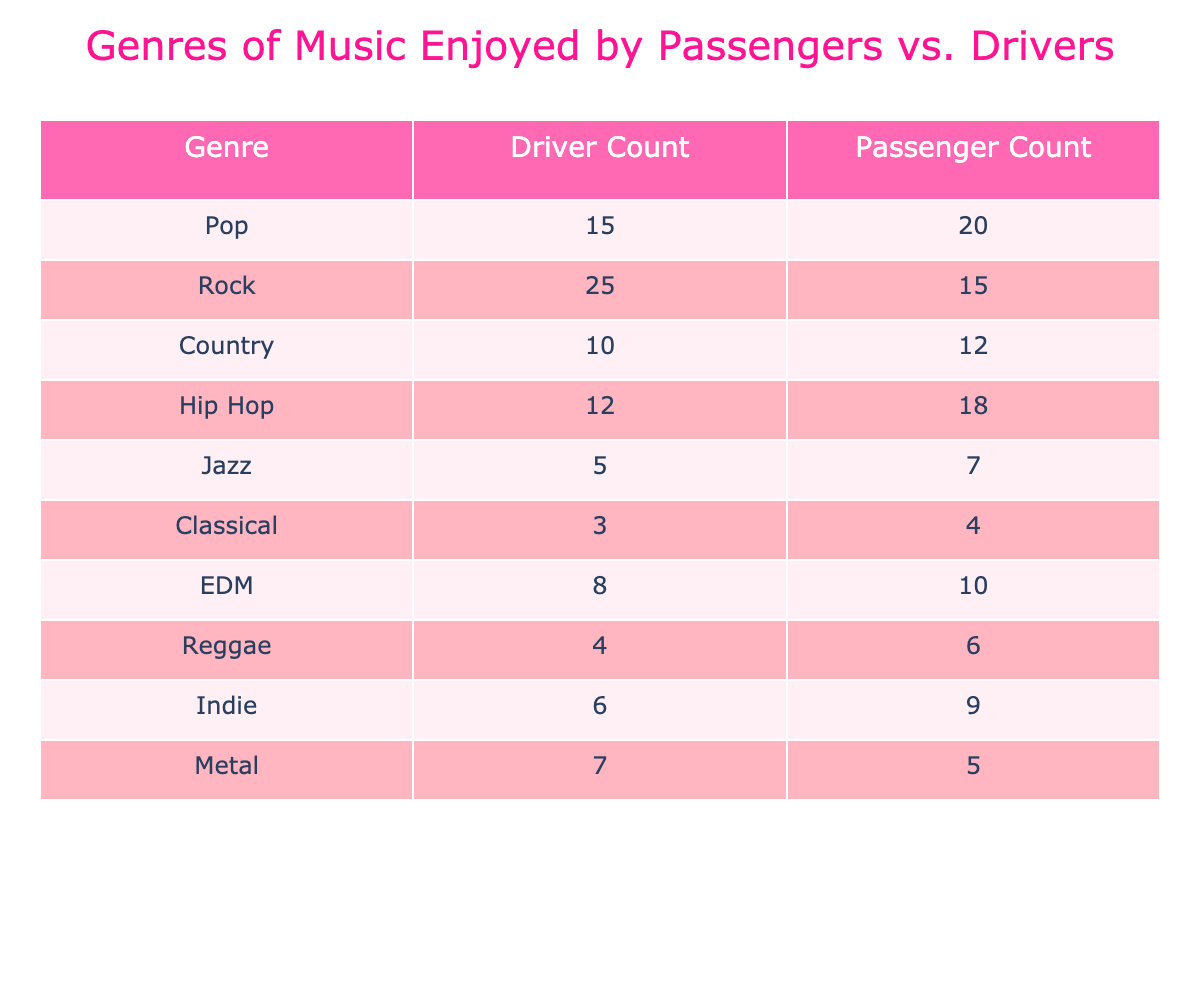What is the total number of drivers who enjoy Rock music? The table shows that the Driver Count for Rock is 25. So, there are 25 drivers who enjoy Rock music.
Answer: 25 Which genre has the highest count of passengers? By looking at the Passenger Count, Pop has the highest number at 20 passengers.
Answer: Pop Is there any genre that has the same count for drivers and passengers? By inspecting the counts, there are no genres where Driver Count is equal to Passenger Count.
Answer: No What is the difference in enjoyment of Hip Hop music between passengers and drivers? For Hip Hop, the Passenger Count is 18 and the Driver Count is 12; thus, the difference is 18 - 12 = 6.
Answer: 6 If we sum the counts for Classical music, how many total people enjoy it? The Driver Count for Classical is 3 and the Passenger Count is 4. Summing these gives 3 + 4 = 7 total people who enjoy Classical music.
Answer: 7 Which genre has the least number of drivers? Checking the Driver Counts, Classical has the least with 3 drivers.
Answer: Classical What is the average number of passengers who enjoy Country and Indie music? The Passenger Count for Country is 12 and for Indie it is 9. The average is (12 + 9) / 2 = 10.5.
Answer: 10.5 Is the total number of drivers who enjoy Country and EDM greater than that of Jazz drivers? The counts are Country 10 and EDM 8 making a total of 10 + 8 = 18 drivers. Jazz has 5 drivers. Since 18 > 5, the statement is true.
Answer: Yes Which genre has the most combined enjoyment (drivers and passengers)? For each genre, we sum the Driver and Passenger Counts. Pop: 35, Rock: 40, Country: 22, Hip Hop: 30, Jazz: 12, Classical: 7, EDM: 18, Reggae: 10, Indie: 15, Metal: 12. Rock has the highest with 40.
Answer: Rock 